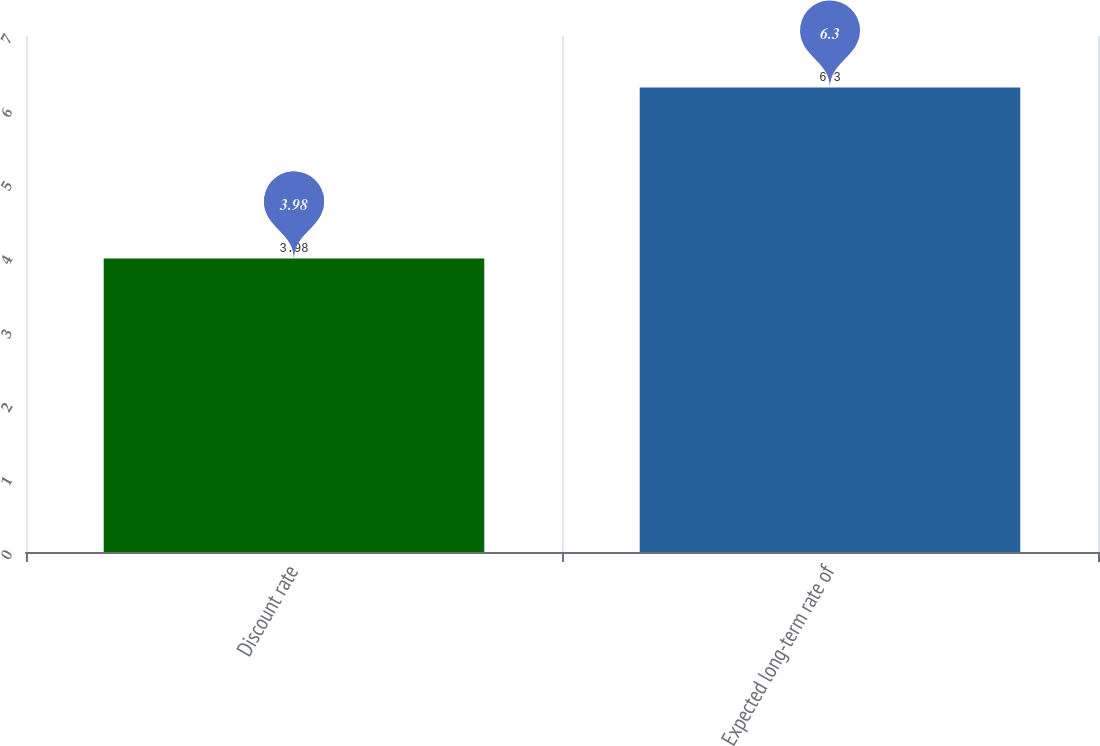<chart> <loc_0><loc_0><loc_500><loc_500><bar_chart><fcel>Discount rate<fcel>Expected long-term rate of<nl><fcel>3.98<fcel>6.3<nl></chart> 